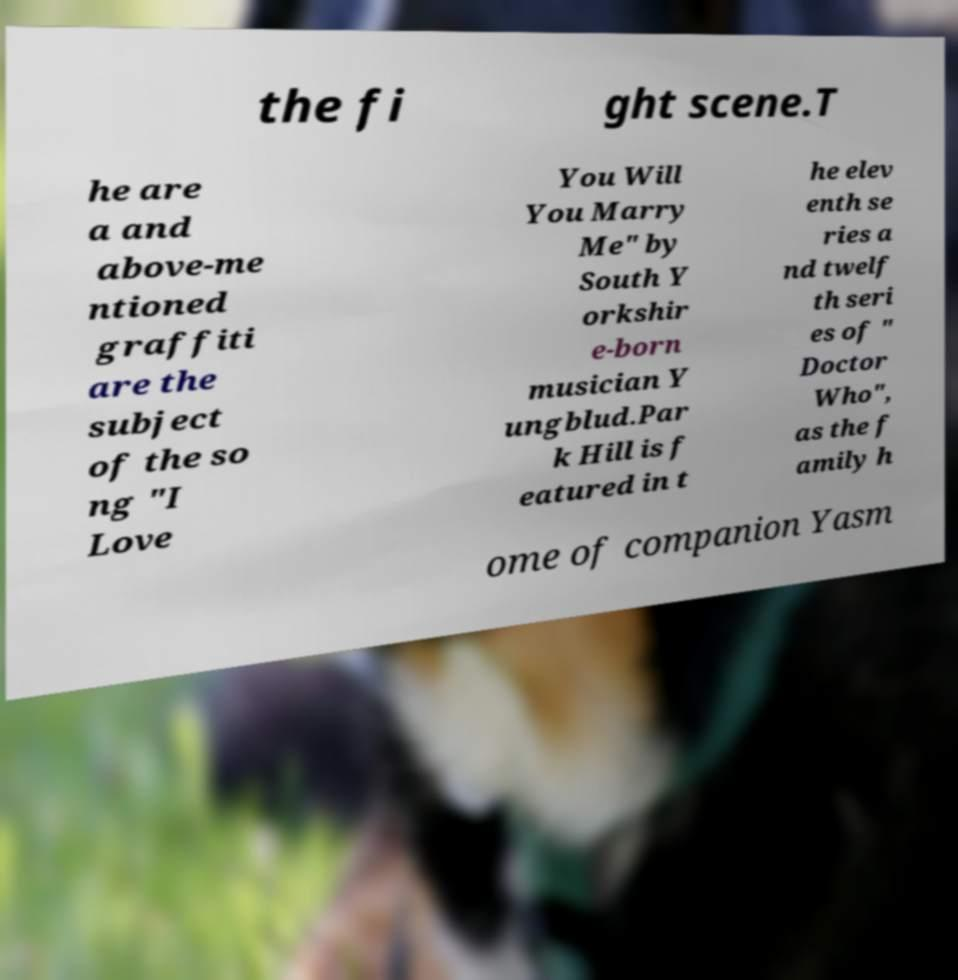Could you extract and type out the text from this image? the fi ght scene.T he are a and above-me ntioned graffiti are the subject of the so ng "I Love You Will You Marry Me" by South Y orkshir e-born musician Y ungblud.Par k Hill is f eatured in t he elev enth se ries a nd twelf th seri es of " Doctor Who", as the f amily h ome of companion Yasm 